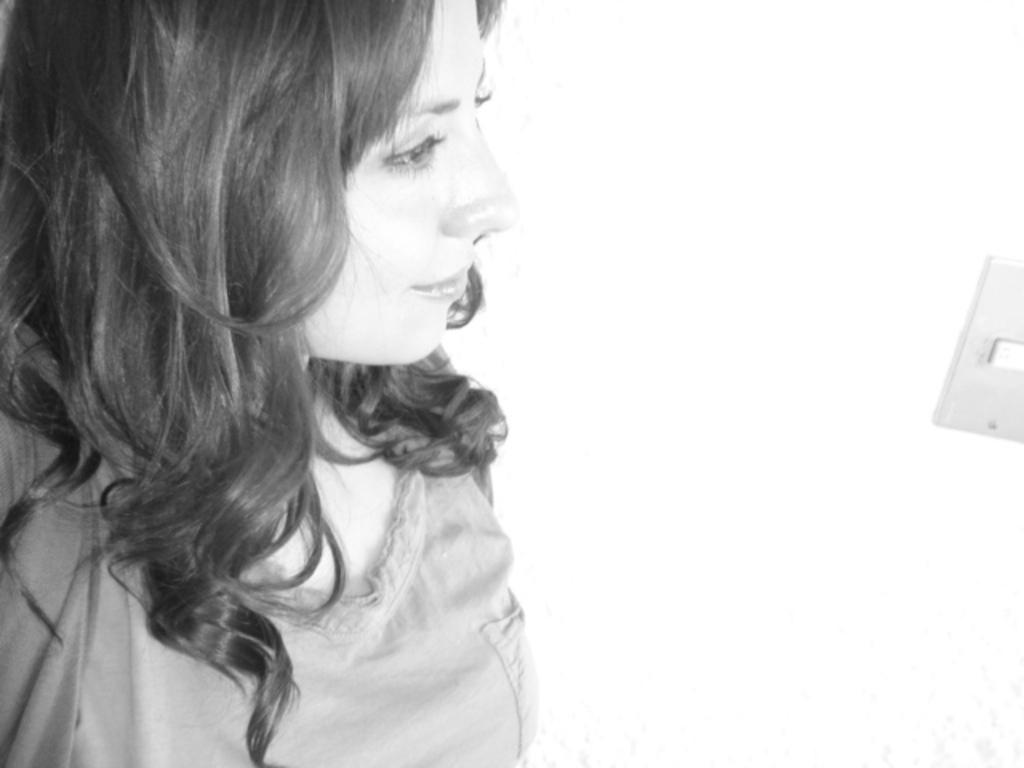Who is present in the image? There is a woman in the image. What is the color scheme of the image? The image is black and white. What type of car can be seen in the image? There is no car present in the image; it only features a woman. How many snakes are visible in the image? There are no snakes present in the image; it only features a woman. 